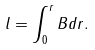<formula> <loc_0><loc_0><loc_500><loc_500>l = \int _ { 0 } ^ { r } B d r .</formula> 